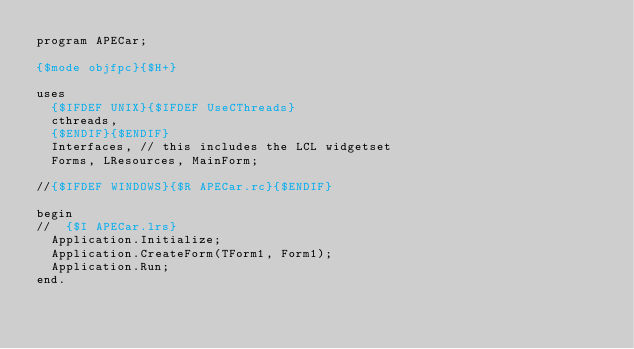Convert code to text. <code><loc_0><loc_0><loc_500><loc_500><_Pascal_>program APECar;

{$mode objfpc}{$H+}

uses
  {$IFDEF UNIX}{$IFDEF UseCThreads}
  cthreads,
  {$ENDIF}{$ENDIF}
  Interfaces, // this includes the LCL widgetset
  Forms, LResources, MainForm;

//{$IFDEF WINDOWS}{$R APECar.rc}{$ENDIF}

begin
//  {$I APECar.lrs}
  Application.Initialize;
  Application.CreateForm(TForm1, Form1);
  Application.Run;
end.

</code> 